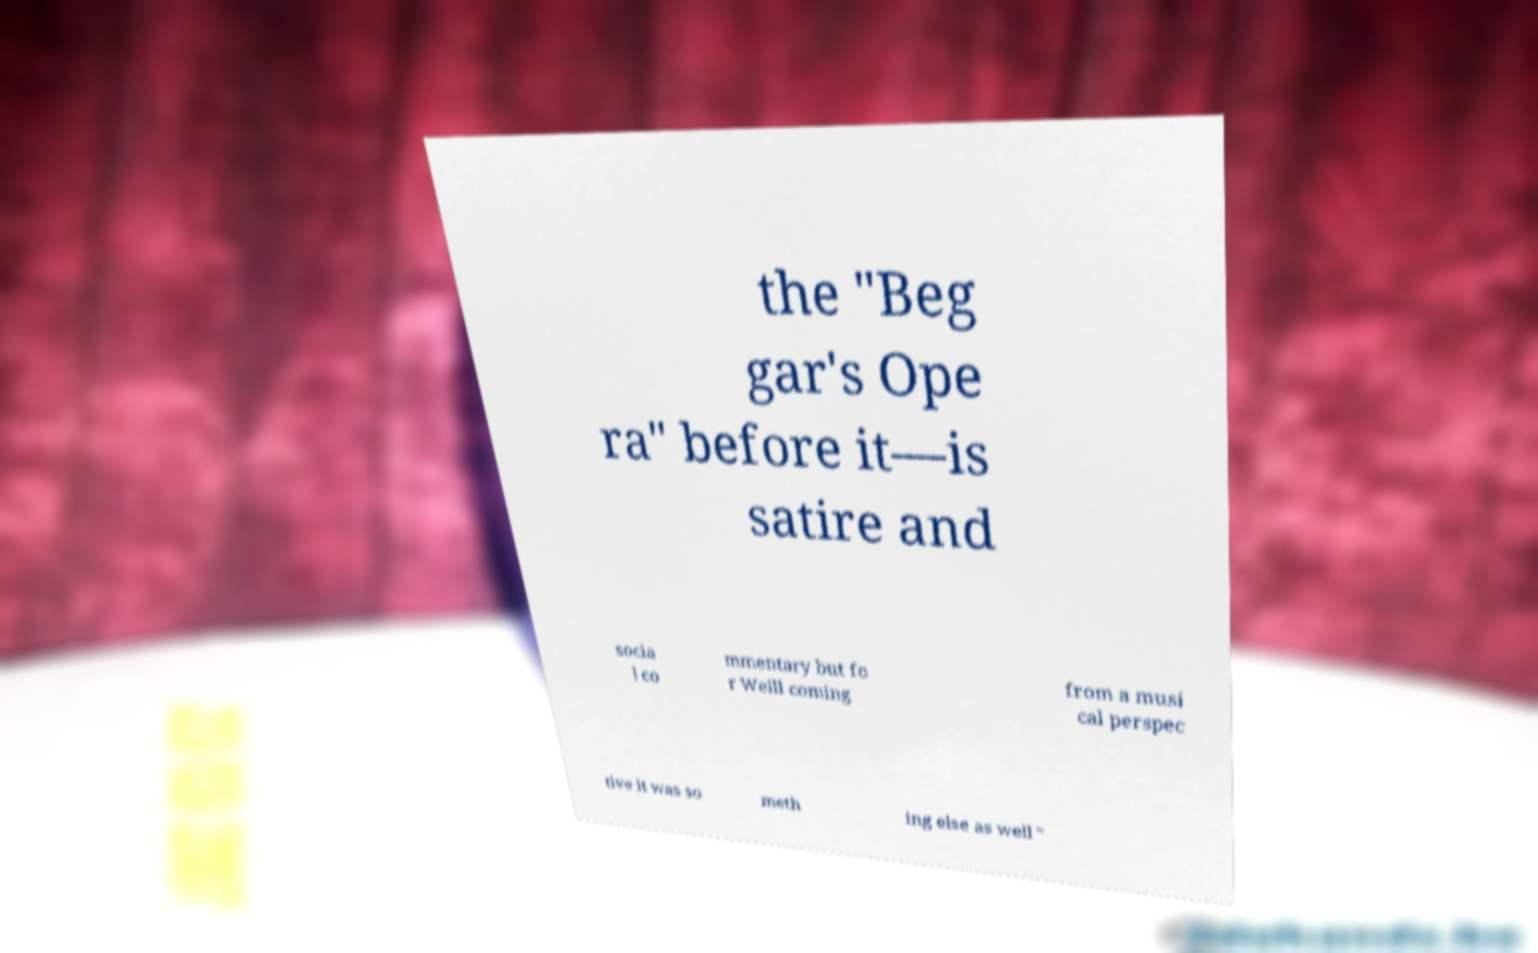Please identify and transcribe the text found in this image. the "Beg gar's Ope ra" before it—is satire and socia l co mmentary but fo r Weill coming from a musi cal perspec tive it was so meth ing else as well " 